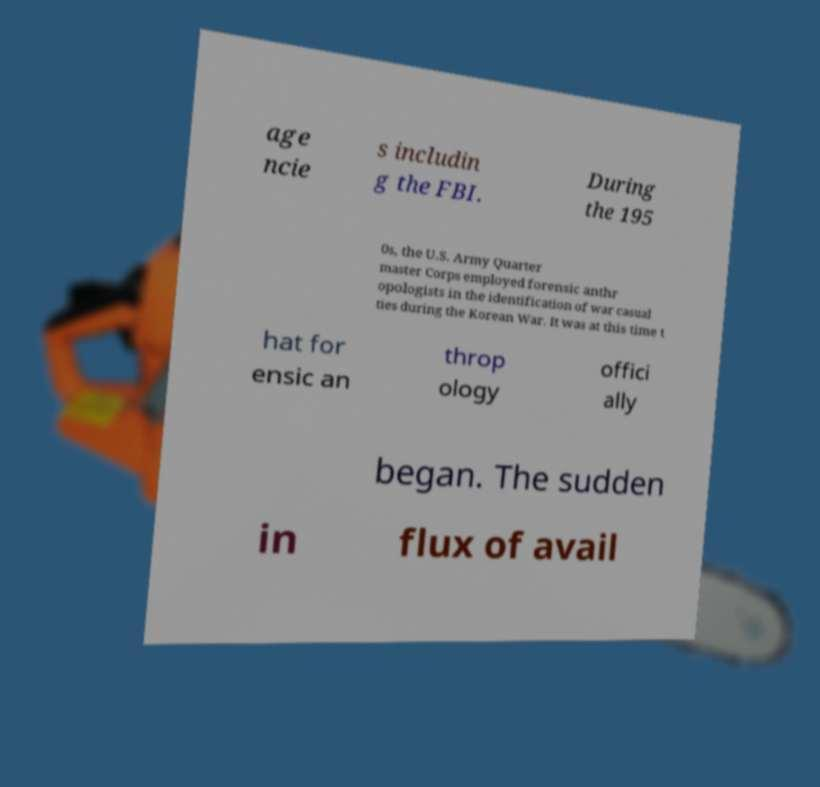Please identify and transcribe the text found in this image. age ncie s includin g the FBI. During the 195 0s, the U.S. Army Quarter master Corps employed forensic anthr opologists in the identification of war casual ties during the Korean War. It was at this time t hat for ensic an throp ology offici ally began. The sudden in flux of avail 